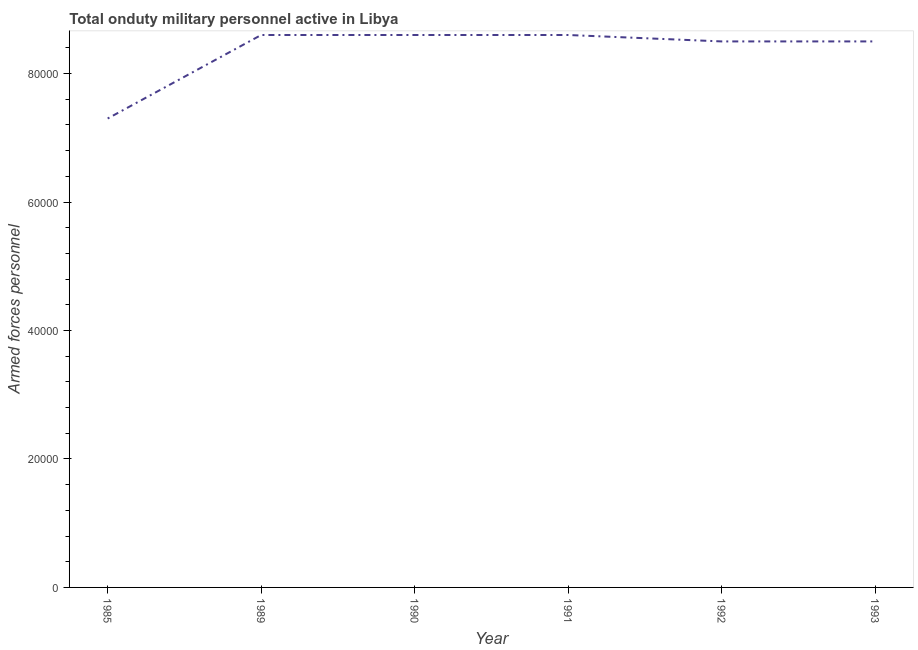What is the number of armed forces personnel in 1985?
Your answer should be very brief. 7.30e+04. Across all years, what is the maximum number of armed forces personnel?
Your answer should be very brief. 8.60e+04. Across all years, what is the minimum number of armed forces personnel?
Provide a succinct answer. 7.30e+04. In which year was the number of armed forces personnel maximum?
Your answer should be very brief. 1989. In which year was the number of armed forces personnel minimum?
Offer a terse response. 1985. What is the sum of the number of armed forces personnel?
Ensure brevity in your answer.  5.01e+05. What is the difference between the number of armed forces personnel in 1985 and 1991?
Your answer should be compact. -1.30e+04. What is the average number of armed forces personnel per year?
Your answer should be very brief. 8.35e+04. What is the median number of armed forces personnel?
Make the answer very short. 8.55e+04. In how many years, is the number of armed forces personnel greater than 80000 ?
Your response must be concise. 5. Is the number of armed forces personnel in 1989 less than that in 1990?
Ensure brevity in your answer.  No. Is the difference between the number of armed forces personnel in 1985 and 1990 greater than the difference between any two years?
Your answer should be compact. Yes. What is the difference between the highest and the lowest number of armed forces personnel?
Offer a very short reply. 1.30e+04. How many lines are there?
Offer a terse response. 1. Are the values on the major ticks of Y-axis written in scientific E-notation?
Make the answer very short. No. Does the graph contain any zero values?
Your answer should be compact. No. Does the graph contain grids?
Offer a terse response. No. What is the title of the graph?
Give a very brief answer. Total onduty military personnel active in Libya. What is the label or title of the X-axis?
Provide a short and direct response. Year. What is the label or title of the Y-axis?
Offer a terse response. Armed forces personnel. What is the Armed forces personnel in 1985?
Provide a succinct answer. 7.30e+04. What is the Armed forces personnel of 1989?
Your response must be concise. 8.60e+04. What is the Armed forces personnel in 1990?
Provide a short and direct response. 8.60e+04. What is the Armed forces personnel of 1991?
Make the answer very short. 8.60e+04. What is the Armed forces personnel in 1992?
Give a very brief answer. 8.50e+04. What is the Armed forces personnel of 1993?
Keep it short and to the point. 8.50e+04. What is the difference between the Armed forces personnel in 1985 and 1989?
Ensure brevity in your answer.  -1.30e+04. What is the difference between the Armed forces personnel in 1985 and 1990?
Ensure brevity in your answer.  -1.30e+04. What is the difference between the Armed forces personnel in 1985 and 1991?
Offer a very short reply. -1.30e+04. What is the difference between the Armed forces personnel in 1985 and 1992?
Provide a short and direct response. -1.20e+04. What is the difference between the Armed forces personnel in 1985 and 1993?
Keep it short and to the point. -1.20e+04. What is the difference between the Armed forces personnel in 1989 and 1990?
Provide a short and direct response. 0. What is the difference between the Armed forces personnel in 1989 and 1991?
Your answer should be compact. 0. What is the difference between the Armed forces personnel in 1989 and 1992?
Offer a very short reply. 1000. What is the difference between the Armed forces personnel in 1990 and 1992?
Make the answer very short. 1000. What is the difference between the Armed forces personnel in 1991 and 1993?
Offer a very short reply. 1000. What is the ratio of the Armed forces personnel in 1985 to that in 1989?
Provide a short and direct response. 0.85. What is the ratio of the Armed forces personnel in 1985 to that in 1990?
Give a very brief answer. 0.85. What is the ratio of the Armed forces personnel in 1985 to that in 1991?
Your answer should be very brief. 0.85. What is the ratio of the Armed forces personnel in 1985 to that in 1992?
Your answer should be very brief. 0.86. What is the ratio of the Armed forces personnel in 1985 to that in 1993?
Offer a very short reply. 0.86. What is the ratio of the Armed forces personnel in 1991 to that in 1992?
Your answer should be compact. 1.01. 